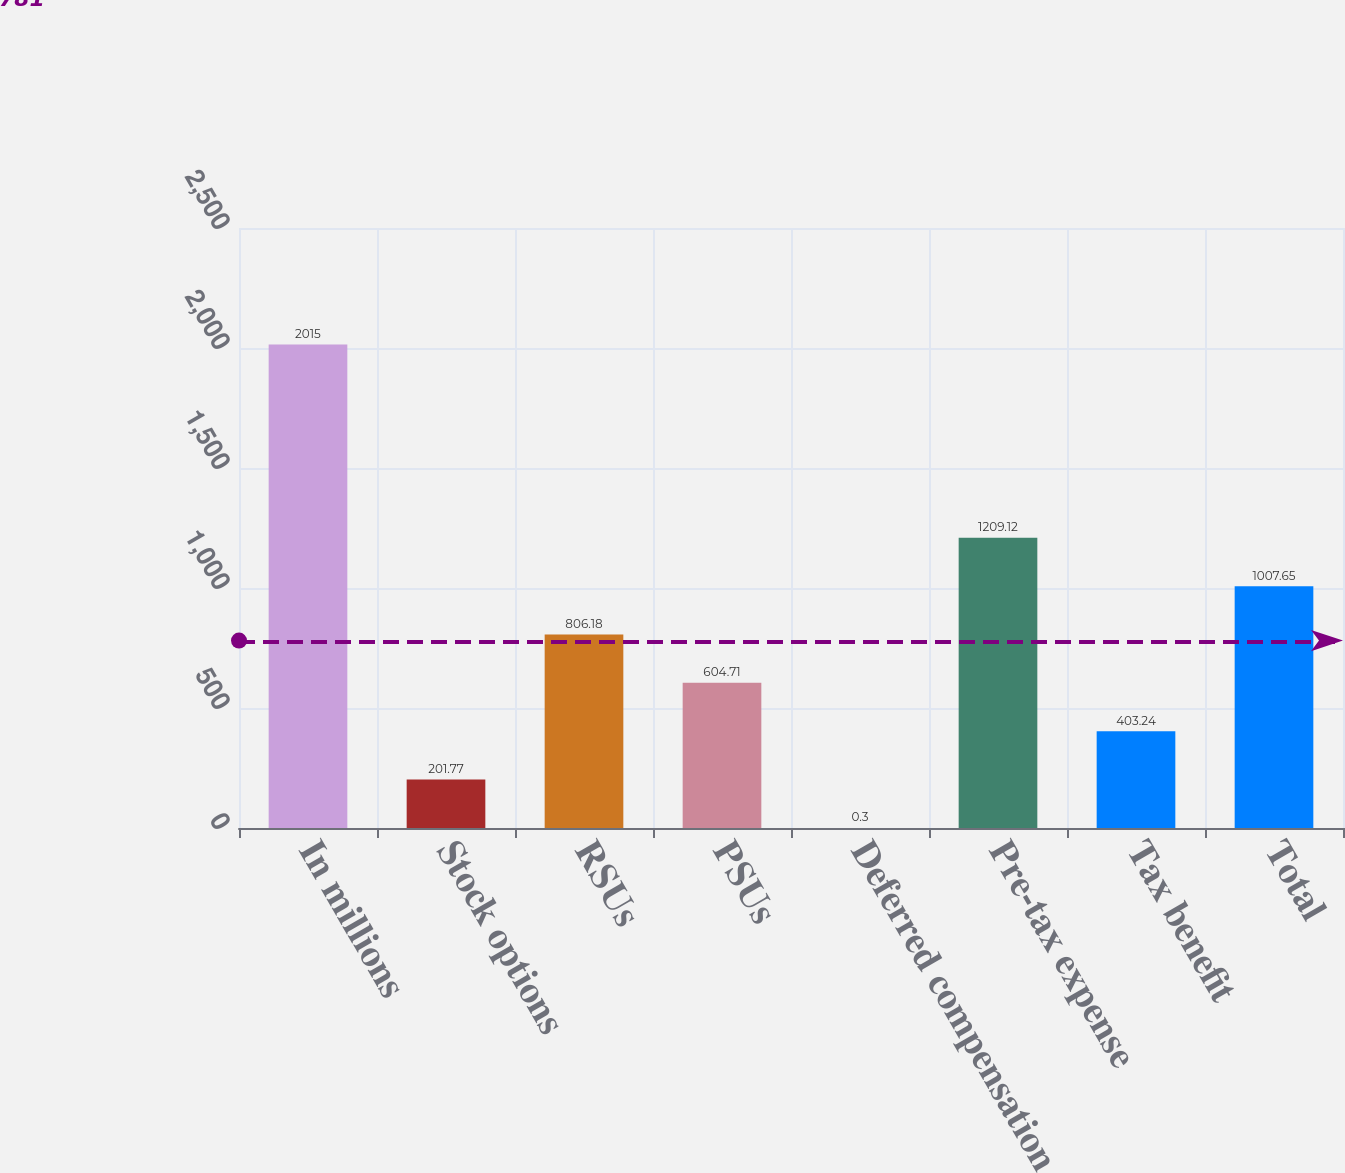Convert chart to OTSL. <chart><loc_0><loc_0><loc_500><loc_500><bar_chart><fcel>In millions<fcel>Stock options<fcel>RSUs<fcel>PSUs<fcel>Deferred compensation<fcel>Pre-tax expense<fcel>Tax benefit<fcel>Total<nl><fcel>2015<fcel>201.77<fcel>806.18<fcel>604.71<fcel>0.3<fcel>1209.12<fcel>403.24<fcel>1007.65<nl></chart> 